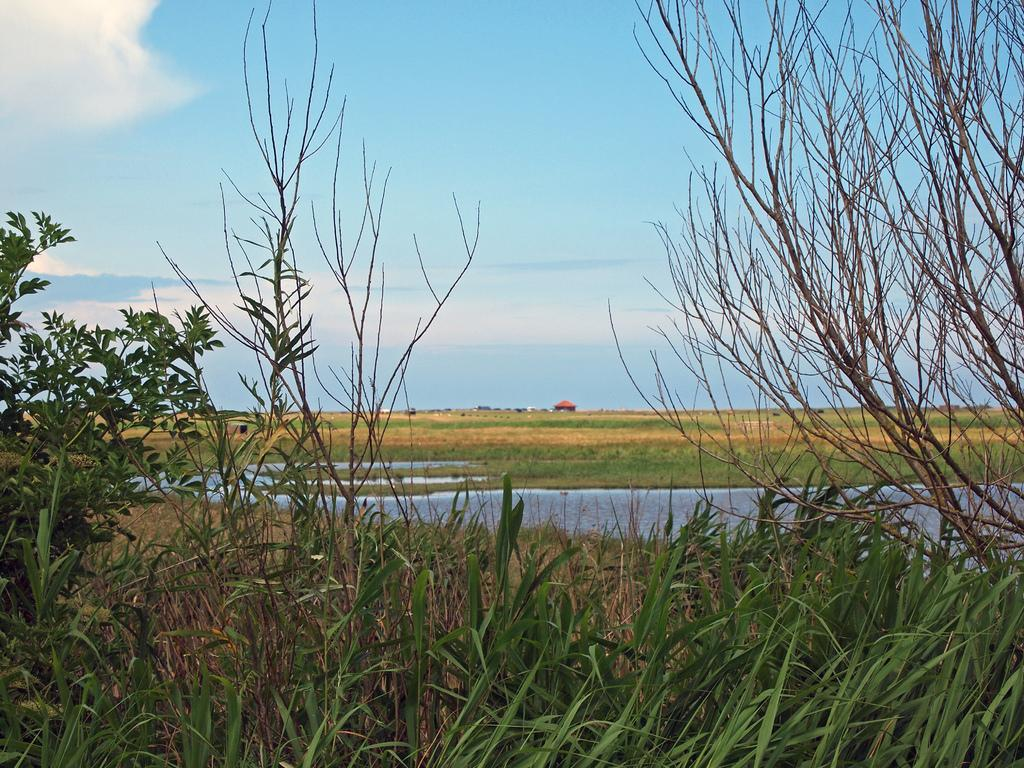What type of vegetation can be seen in the image? There is grass in the image. Are there any other plants visible in the image? Yes, there are trees in the image. What can be seen in the background of the image? The sky is visible in the background of the image. What is the condition of the sky in the image? Clouds are present in the sky. How many eggs are being digested by the ants in the image? There are no ants or eggs present in the image. What type of digestion process can be observed in the image? There is no digestion process visible in the image; it features grass, trees, and a sky with clouds. 